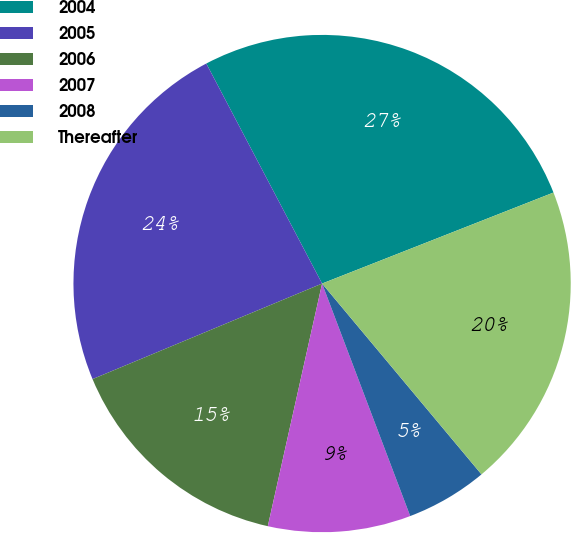Convert chart. <chart><loc_0><loc_0><loc_500><loc_500><pie_chart><fcel>2004<fcel>2005<fcel>2006<fcel>2007<fcel>2008<fcel>Thereafter<nl><fcel>26.75%<fcel>23.57%<fcel>15.22%<fcel>9.27%<fcel>5.31%<fcel>19.89%<nl></chart> 